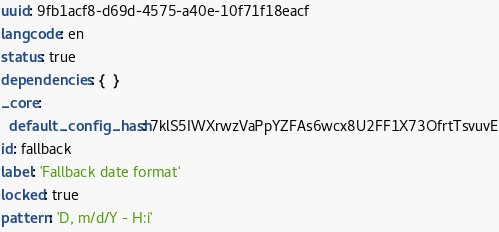<code> <loc_0><loc_0><loc_500><loc_500><_YAML_>uuid: 9fb1acf8-d69d-4575-a40e-10f71f18eacf
langcode: en
status: true
dependencies: {  }
_core:
  default_config_hash: 7klS5IWXrwzVaPpYZFAs6wcx8U2FF1X73OfrtTsvuvE
id: fallback
label: 'Fallback date format'
locked: true
pattern: 'D, m/d/Y - H:i'
</code> 